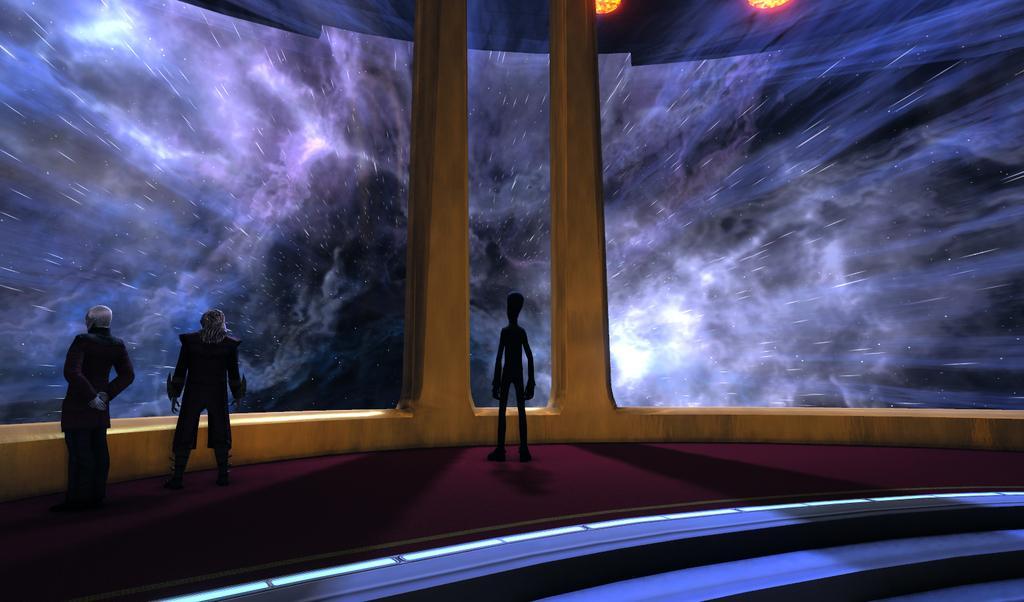Can you describe this image briefly? This is an animated image. In this image we can see the depictions of the persons, in front of them there is a glass through which we can see the thunders in the sky. 